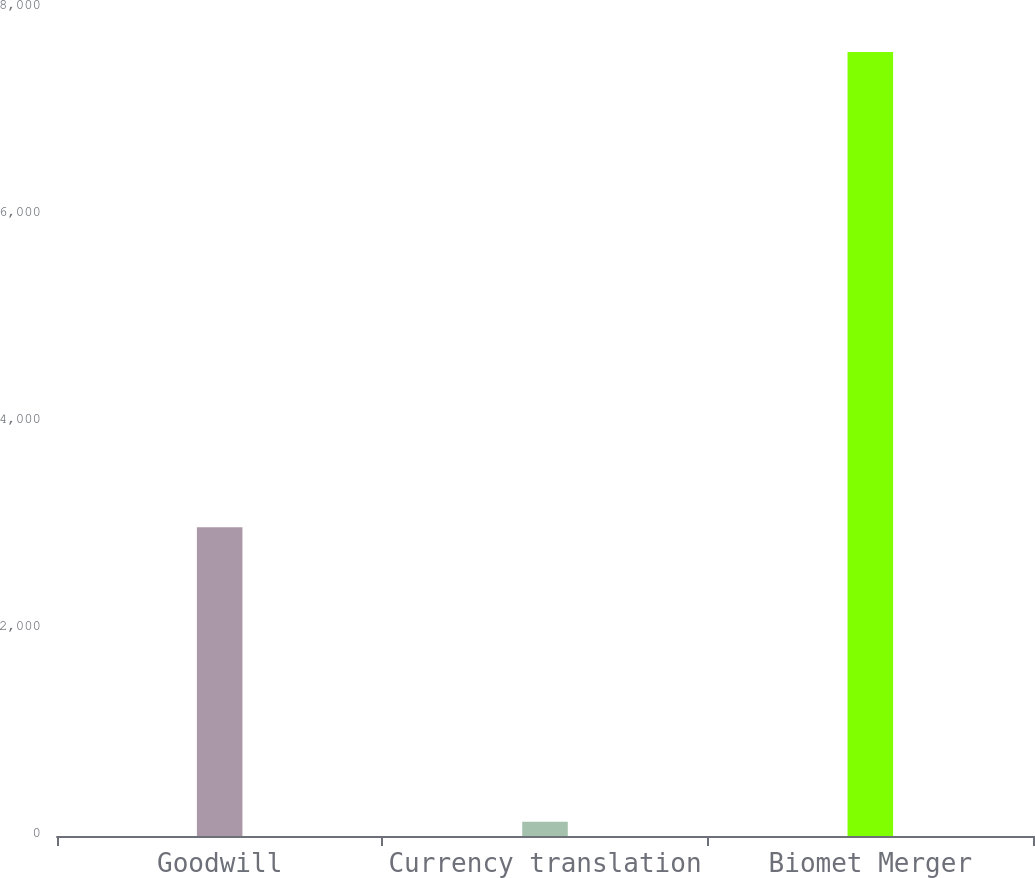Convert chart to OTSL. <chart><loc_0><loc_0><loc_500><loc_500><bar_chart><fcel>Goodwill<fcel>Currency translation<fcel>Biomet Merger<nl><fcel>2984.2<fcel>137.6<fcel>7573.9<nl></chart> 